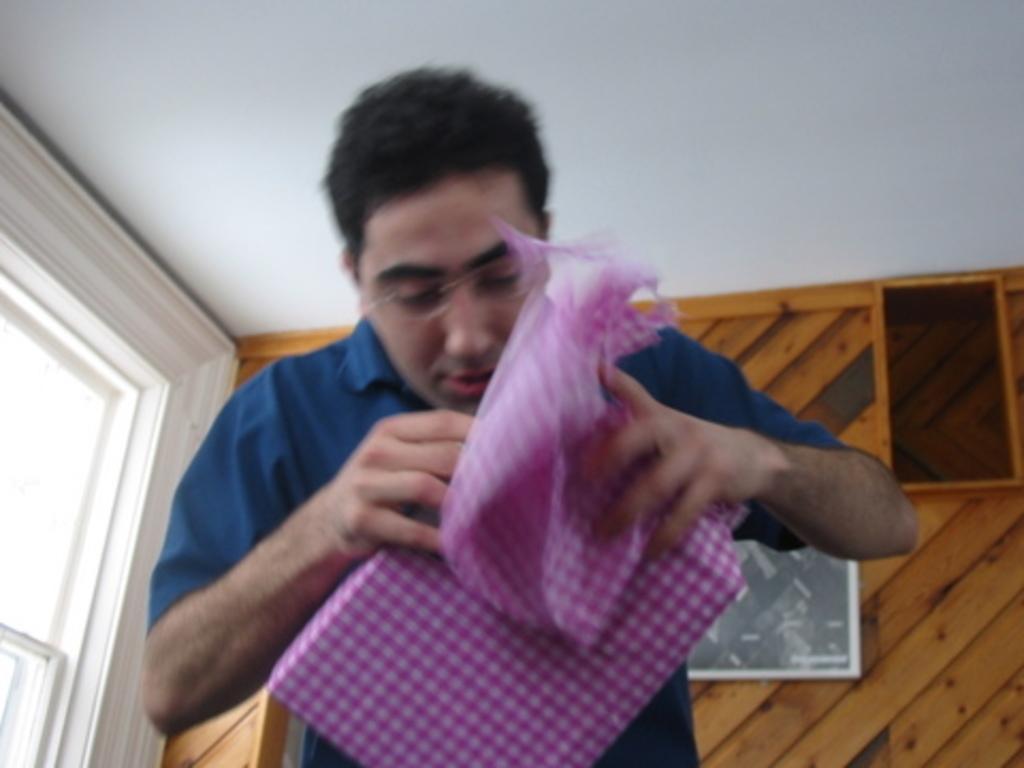How would you summarize this image in a sentence or two? In this picture we can see a person, he is holding an object and in the background we can see a roof and some objects. 